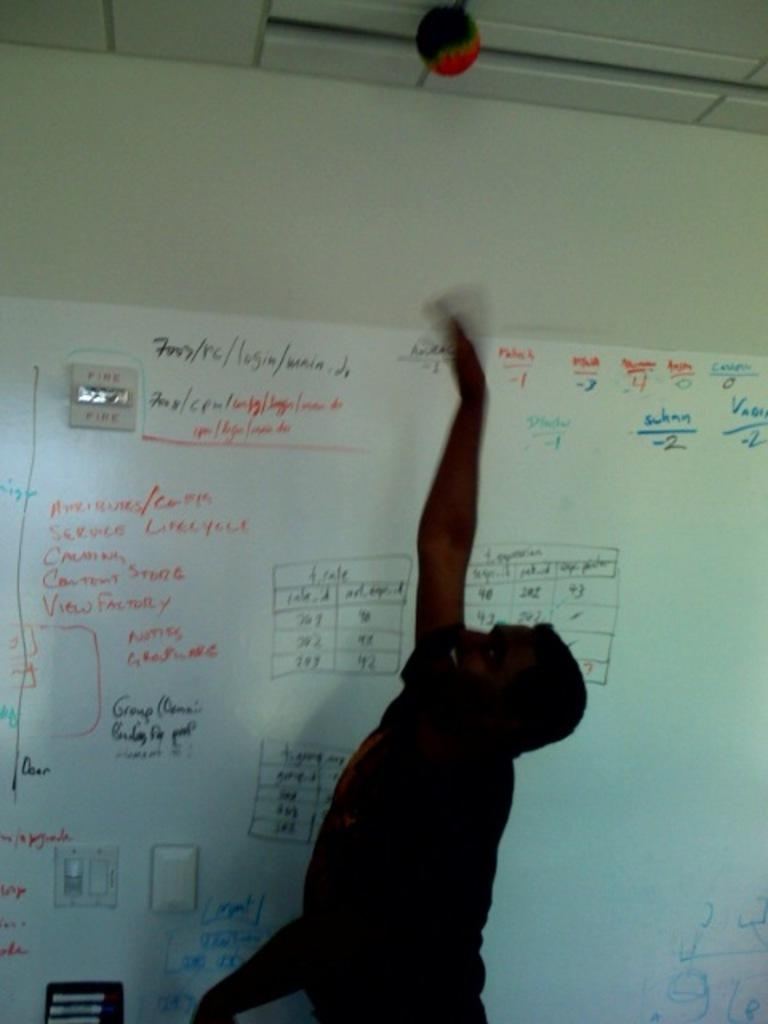<image>
Relay a brief, clear account of the picture shown. A man in front of a whiteboard that says Group is throwing a ball in the air. 